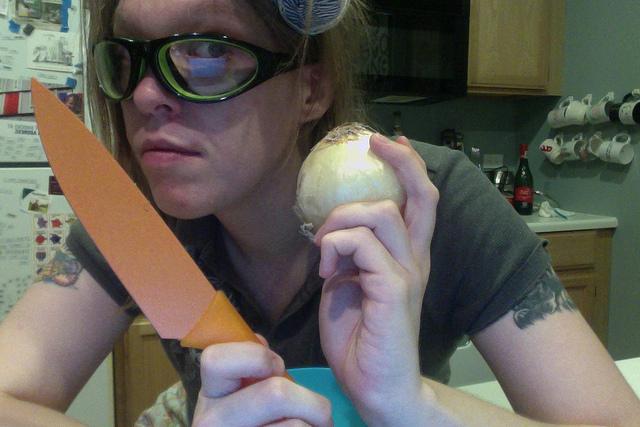Why is she wearing goggles?
Give a very brief answer. Cutting onion. Is she trying to cut an onion?
Answer briefly. No. Is the girl young?
Give a very brief answer. Yes. 